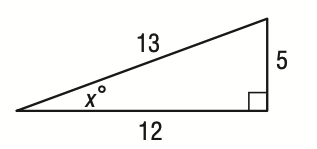Question: What is the value of \tan x?
Choices:
A. \frac { 5 } { 13 }
B. \frac { 5 } { 12 }
C. \frac { 12 } { 5 }
D. \frac { 13 } { 5 }
Answer with the letter. Answer: B 